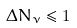Convert formula to latex. <formula><loc_0><loc_0><loc_500><loc_500>\Delta N _ { \nu } \leq 1</formula> 